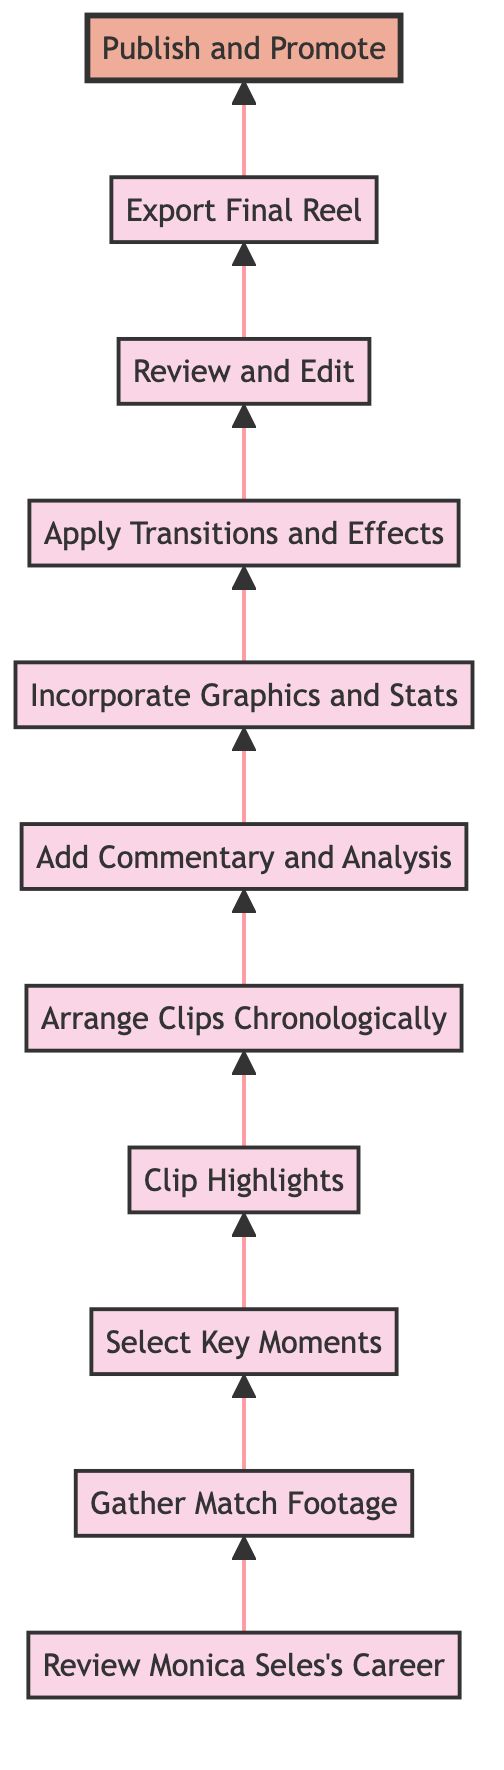What is the first step in creating the highlight reel? The diagram shows that the first step is "Review Monica Seles's Career," which is the initial node at the bottom of the flow chart.
Answer: Review Monica Seles's Career How many steps are involved in the workflow? By counting the number of nodes in the flow chart, there are 11 different steps involved, from "Review Monica Seles's Career" to "Publish and Promote."
Answer: 11 What is the final step in the workflow? The last node in the flow is "Publish and Promote," indicating that this is the final action to complete the highlight reel process.
Answer: Publish and Promote What precedes the "Review and Edit" step? The step before "Review and Edit" is "Apply Transitions and Effects," which means that transitions and effects must be included before conducting a review.
Answer: Apply Transitions and Effects Which step focuses on integrating graphics? The step "Incorporate Graphics and Stats" refers specifically to adding graphics and stats, indicating its focus on enhancing the viewer's experience visually.
Answer: Incorporate Graphics and Stats How is the highlight reel expected to maintain narrative flow? The step that addresses maintaining narrative flow is "Arrange Clips Chronologically," meaning that the clips should be organized in the order they occurred in the matches.
Answer: Arrange Clips Chronologically After selecting key moments, what is the next action to be taken? Following the selection of key moments, the immediate action to be taken is "Clip Highlights," which entails extracting video clips of those selected moments.
Answer: Clip Highlights What type of content is added after the clips are arranged? After arranging the clips, the next content that is added is "Add Commentary and Analysis," which provides insights specific to Monica Seles's performance in the matches.
Answer: Add Commentary and Analysis What is the main purpose of the "Export Final Reel" step? The "Export Final Reel" step is meant to generate the completed highlight reel in a high-resolution format, ensuring it is suitable for broadcasting.
Answer: Export Final Reel Which step follows gathering match footage? The step directly following "Gather Match Footage" is "Select Key Moments," which indicates that once footage is collected, the next action is to choose the important parts from it.
Answer: Select Key Moments 